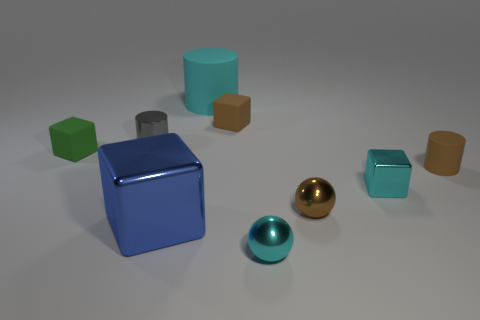Is the large rubber object the same color as the small metallic block?
Your answer should be compact. Yes. There is a cylinder that is the same color as the tiny metallic block; what is it made of?
Offer a very short reply. Rubber. How many metallic objects are either large blocks or tiny brown spheres?
Keep it short and to the point. 2. What number of small blocks are right of the gray thing left of the cyan shiny sphere?
Your response must be concise. 2. There is a brown thing that is both on the left side of the brown cylinder and in front of the gray object; what is its shape?
Your answer should be compact. Sphere. What is the material of the cyan thing that is on the left side of the small matte cube behind the small cylinder that is on the left side of the tiny cyan sphere?
Your answer should be very brief. Rubber. What size is the rubber object that is the same color as the small metal cube?
Your answer should be very brief. Large. What is the material of the brown cylinder?
Ensure brevity in your answer.  Rubber. Do the green block and the cylinder that is behind the tiny gray object have the same material?
Ensure brevity in your answer.  Yes. What color is the rubber thing in front of the tiny green block that is left of the small shiny cube?
Ensure brevity in your answer.  Brown. 